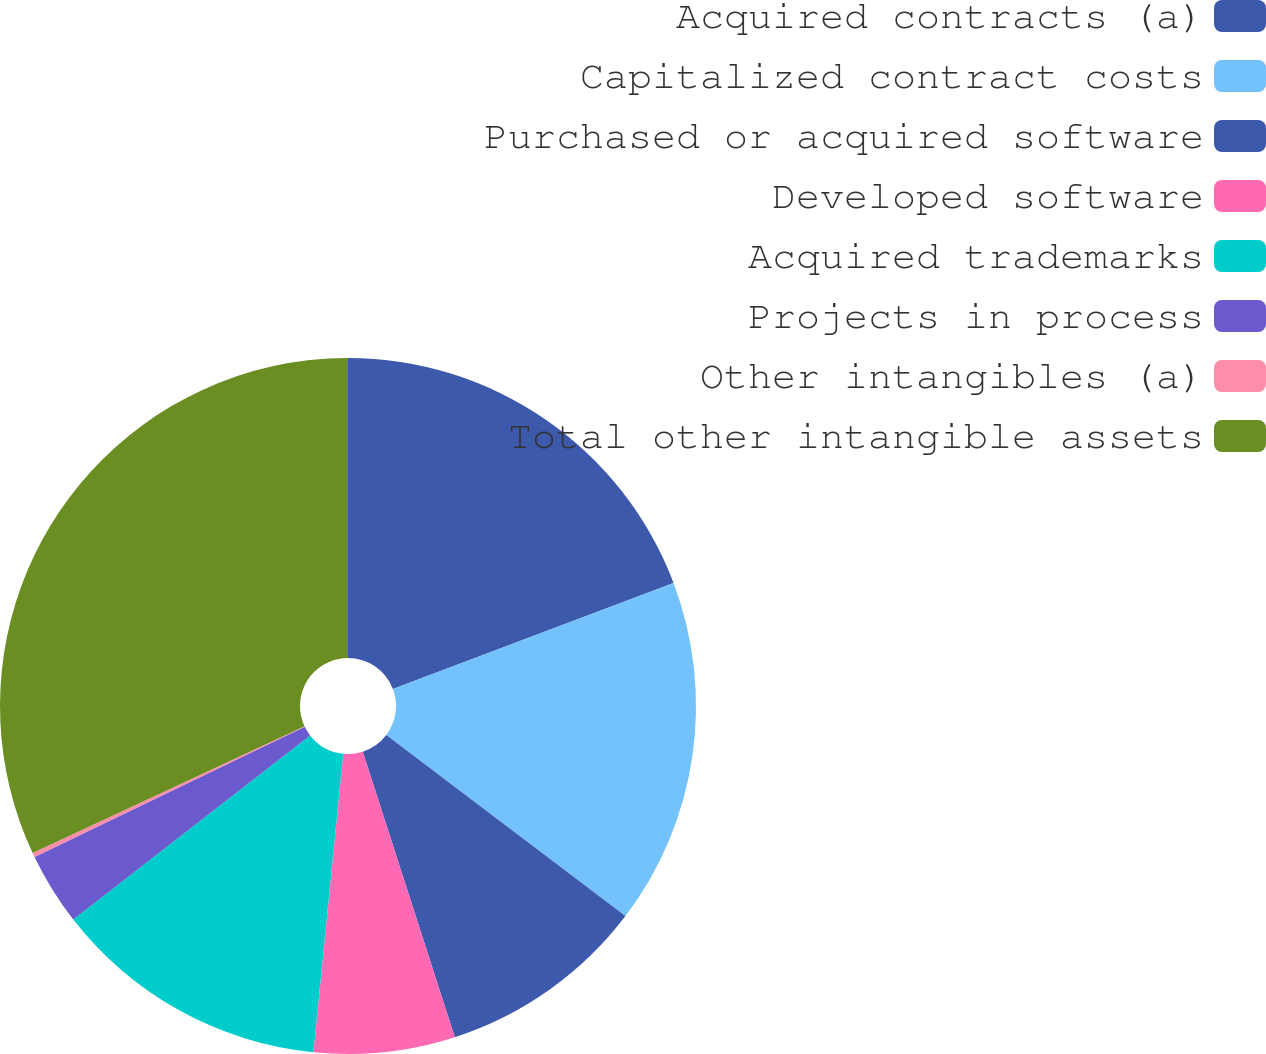Convert chart to OTSL. <chart><loc_0><loc_0><loc_500><loc_500><pie_chart><fcel>Acquired contracts (a)<fcel>Capitalized contract costs<fcel>Purchased or acquired software<fcel>Developed software<fcel>Acquired trademarks<fcel>Projects in process<fcel>Other intangibles (a)<fcel>Total other intangible assets<nl><fcel>19.25%<fcel>16.07%<fcel>9.72%<fcel>6.55%<fcel>12.9%<fcel>3.37%<fcel>0.2%<fcel>31.95%<nl></chart> 